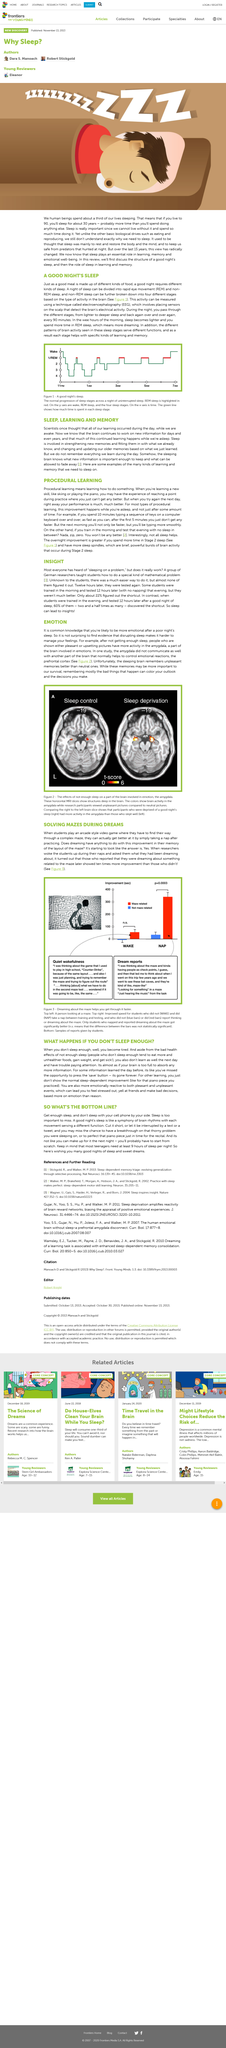Indicate a few pertinent items in this graphic. With excitement and anticipation, the students were engrossed in an arcade style video game with a complex maze, where they were challenged to navigate their way to the end. Sleep deprivation has been shown to affect the amygdala in the brain, as demonstrated in Figure 2. Studies have shown that individuals who are sleep deprived and shown either pleasant or upsetting pictures exhibit increased activity in the amygdala, a region of the brain associated with emotional processing. The x-axis of a chart representing a good night's sleep represents time. Most teenagers require an average of 9 hours of sleep per night to meet their needs, as determined by research. 